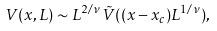Convert formula to latex. <formula><loc_0><loc_0><loc_500><loc_500>V ( x , L ) \sim L ^ { 2 / \nu } \tilde { V } ( ( x - x _ { c } ) L ^ { 1 / \nu } ) ,</formula> 